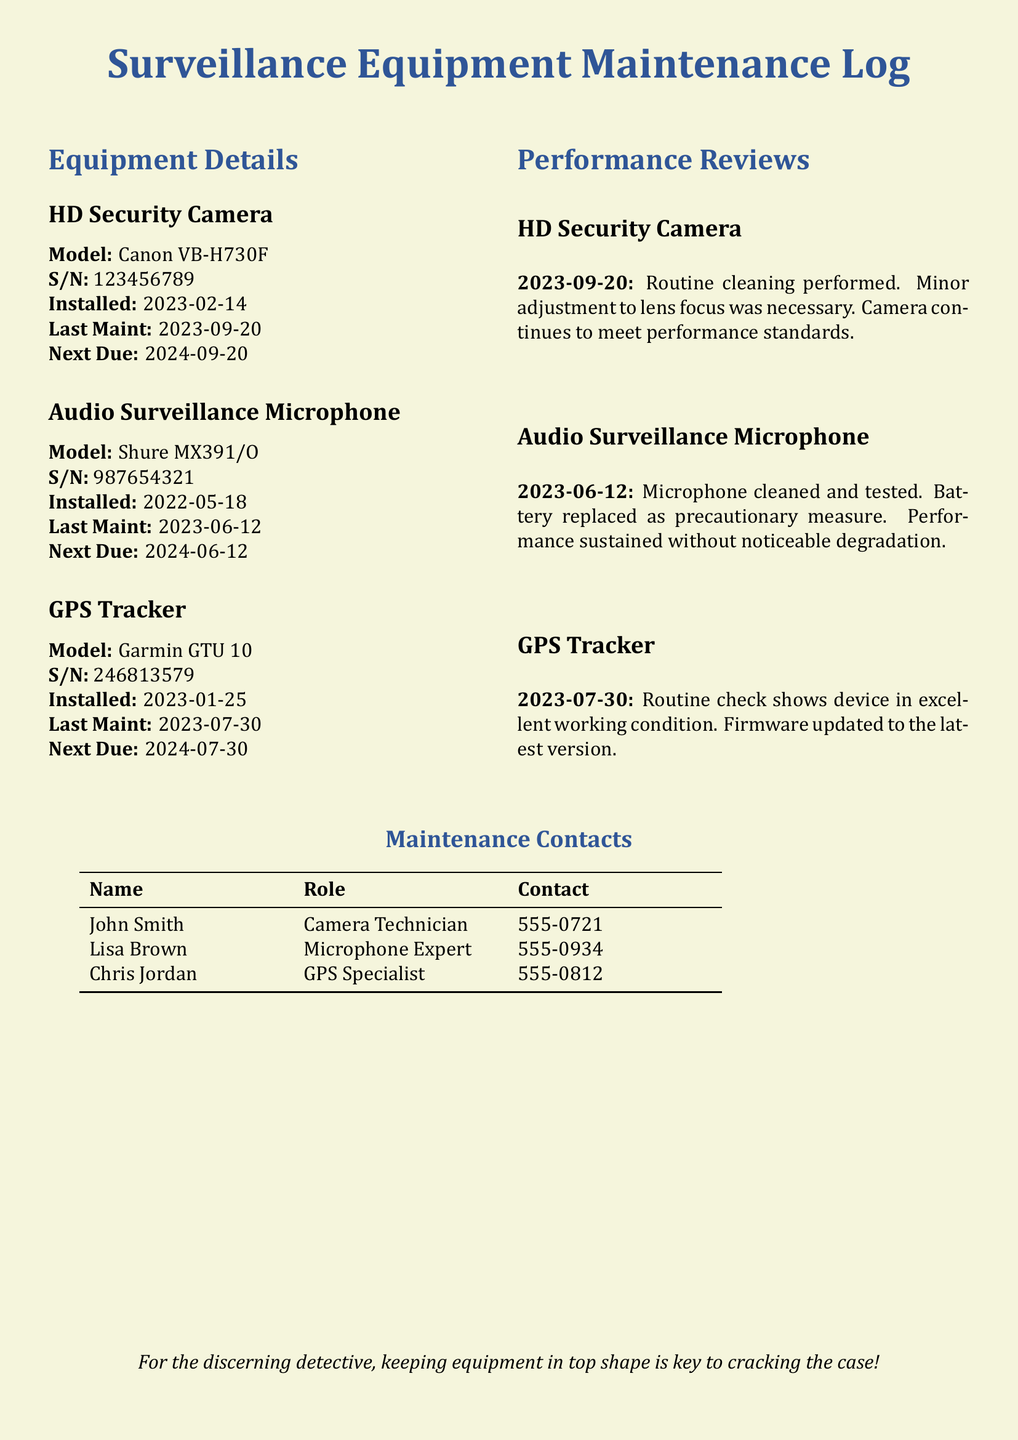What is the model of the HD Security Camera? The HD Security Camera model is specified in the document.
Answer: Canon VB-H730F When was the last maintenance of the Audio Surveillance Microphone? The document states the date of the last maintenance for the Audio Surveillance Microphone.
Answer: 2023-06-12 Who is the GPS Specialist? The document lists individuals responsible for maintenance, including their roles.
Answer: Chris Jordan What was performed on the HD Security Camera during the last review? The document explains the actions taken during the performance review of the HD Security Camera.
Answer: Routine cleaning What is the next due maintenance date for the Audio Surveillance Microphone? The next due maintenance date is explicitly mentioned in the document.
Answer: 2024-06-12 How many pieces of equipment are listed in this log? The document presents separate maintenance details for specific types of surveillance equipment.
Answer: 3 What precautionary measure was taken for the Audio Surveillance Microphone? The performance review includes details about maintenance actions taken, including precautionary measures.
Answer: Battery replaced What is the contact number for the Camera Technician? The maintenance contacts section lists specific individuals and their contact information.
Answer: 555-0721 What action was taken during the GPS Tracker's last maintenance? The performance review for the GPS Tracker indicates what actions were implemented during maintenance.
Answer: Firmware updated to the latest version 